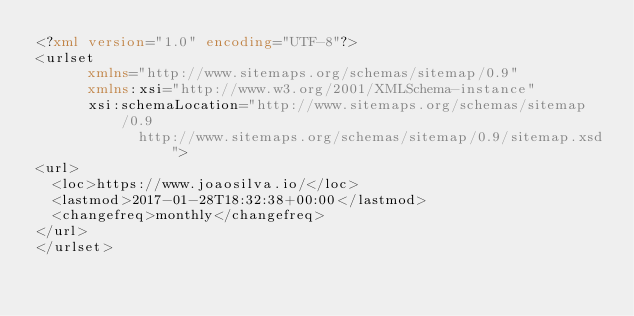<code> <loc_0><loc_0><loc_500><loc_500><_XML_><?xml version="1.0" encoding="UTF-8"?>
<urlset
      xmlns="http://www.sitemaps.org/schemas/sitemap/0.9"
      xmlns:xsi="http://www.w3.org/2001/XMLSchema-instance"
      xsi:schemaLocation="http://www.sitemaps.org/schemas/sitemap/0.9
            http://www.sitemaps.org/schemas/sitemap/0.9/sitemap.xsd">
<url>
  <loc>https://www.joaosilva.io/</loc>
  <lastmod>2017-01-28T18:32:38+00:00</lastmod>
  <changefreq>monthly</changefreq>
</url>
</urlset></code> 